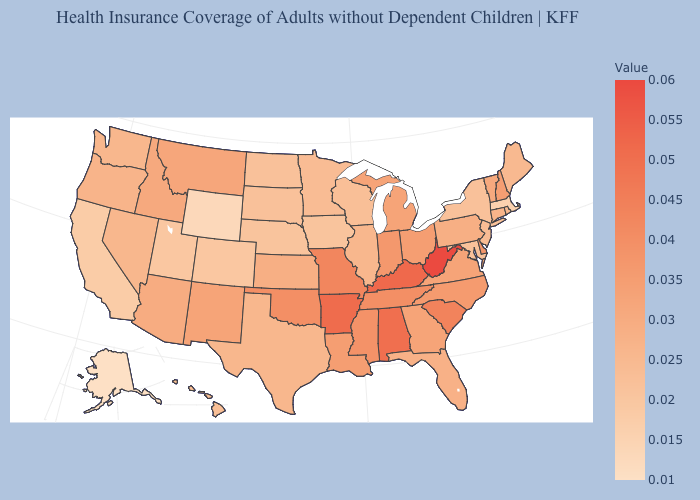Among the states that border Nevada , which have the highest value?
Be succinct. Idaho. Which states hav the highest value in the Northeast?
Quick response, please. New Hampshire. Among the states that border Tennessee , does Mississippi have the highest value?
Short answer required. No. Which states have the lowest value in the West?
Keep it brief. Alaska. 